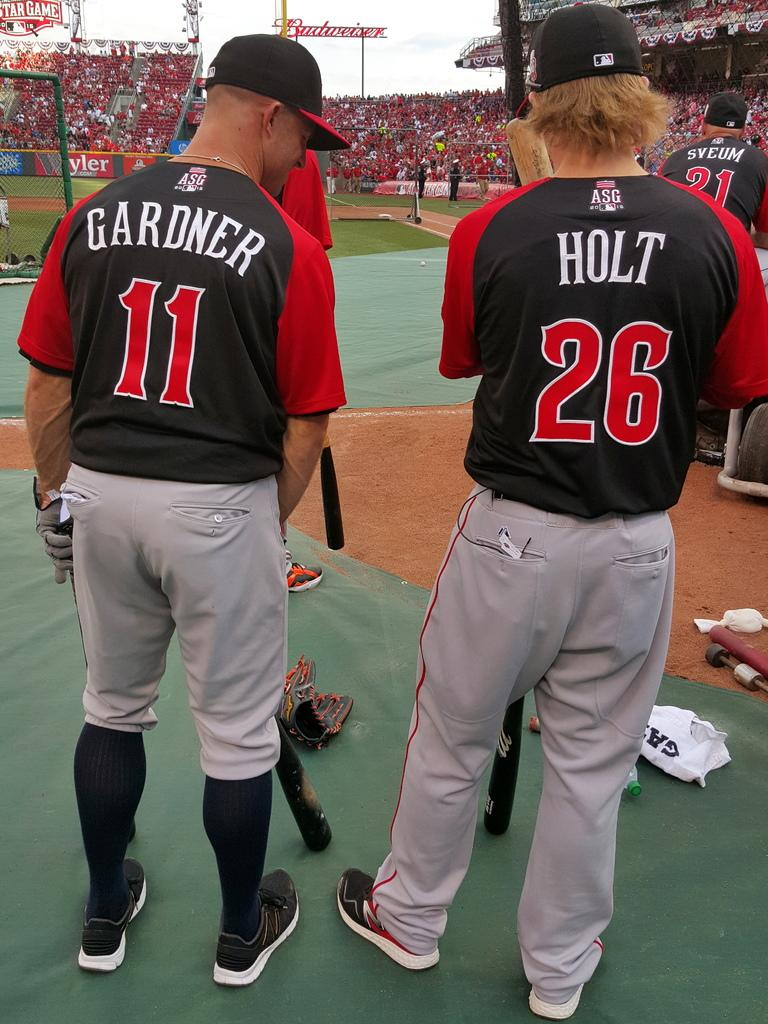<image>
Describe the image concisely. a person in a Gardner 11 shirt stands next to another in a Holt 26 shirt 